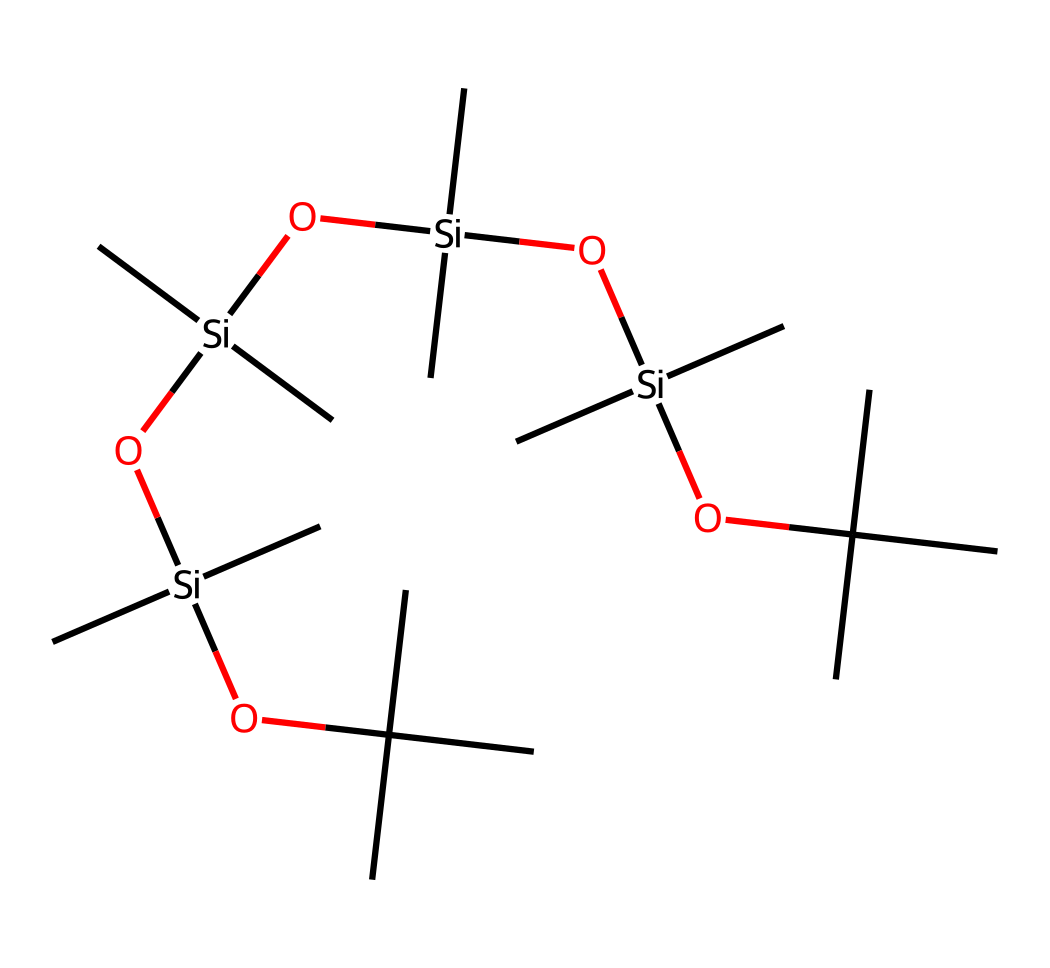what is the core element in this chemical structure? The core element in the structure can be identified as silicon, which is represented by the [Si] notation in the SMILES representation. This indicates the presence of silicon atoms in the organosilicon compound.
Answer: silicon how many silicon atoms are present in this molecule? By analyzing the SMILES notation, we count the instances of [Si], which appear four times in the structure, indicating the presence of four silicon atoms.
Answer: four what type of functional groups are present in this compound? The structure shows hydroxyl groups (indicated by 'O' bonded to silicon) and alkyl groups (represented by the 'C' branches), suggesting the presence of both silanol (OH) and alkyl functional groups.
Answer: silanol and alkyl how many oxygen atoms are present in the structure? The number of oxygen atoms can be determined by counting the occurrences of 'O' in the SMILES representation: there are three 'O' connected directly to the silicon atoms.
Answer: three what type of bonding is primarily present in this silicone compound? The compound showcases mainly covalent bonds, indicated by the connectivity of silicon atoms with both carbon and oxygen atoms, allowing for stable interactions typical of organosilicon compounds.
Answer: covalent what property makes this compound suitable as a lubricant? The presence of long alkyl chains and the ability to form a viscous and flexible structure contribute to its lubricating properties, as these features help reduce friction and improve performance in gear and mechanical components.
Answer: low friction how does the branched alkyl groups affect the silicone's performance? Branched alkyl groups increase the viscosity and thermal stability of the lubricant, preventing it from thinning out at high temperatures and enhancing its retention on surfaces, which is critical for maintaining lubrication in outdoor conditions.
Answer: increases viscosity and stability 